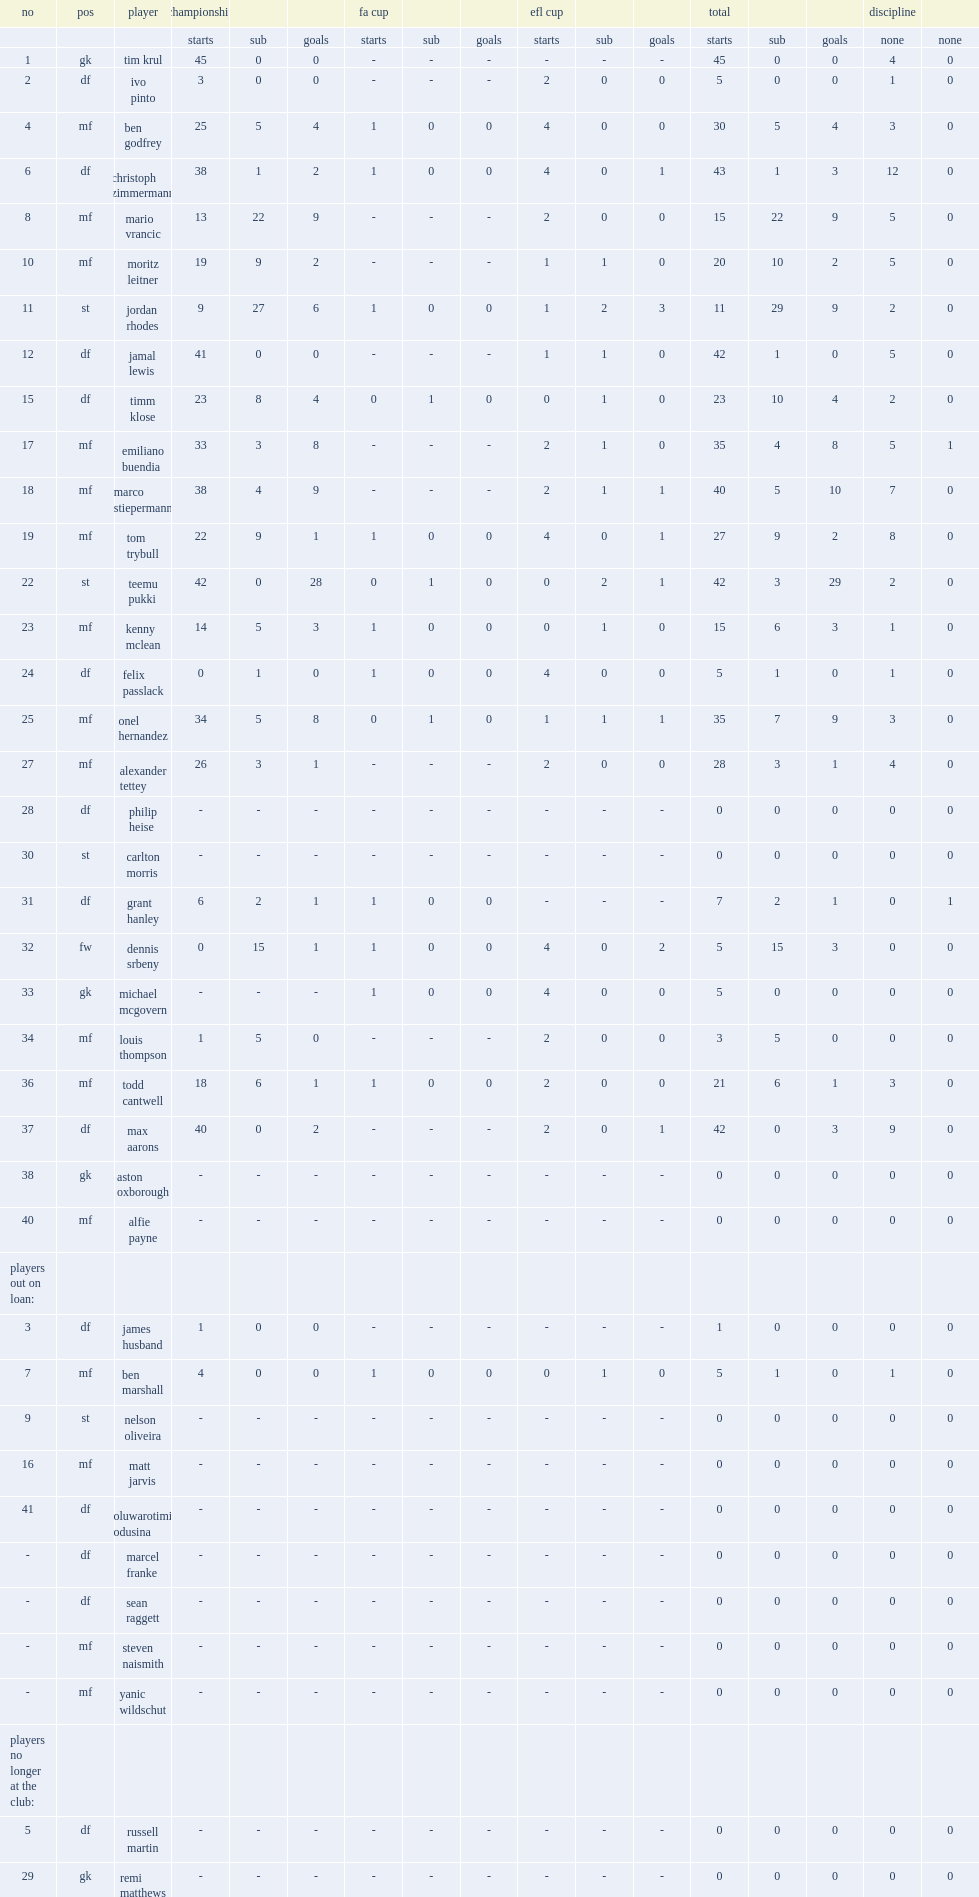In the 2018-19 season, which games did norwich city f.c. participate in? Championship fa cup efl cup. 